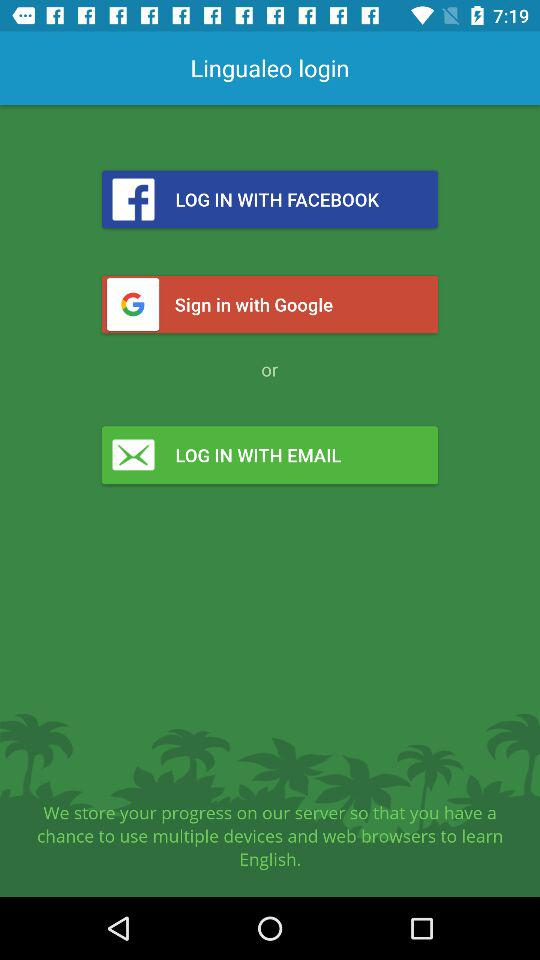What applications can be used for login? You can login with Facebook, Google and Email. 